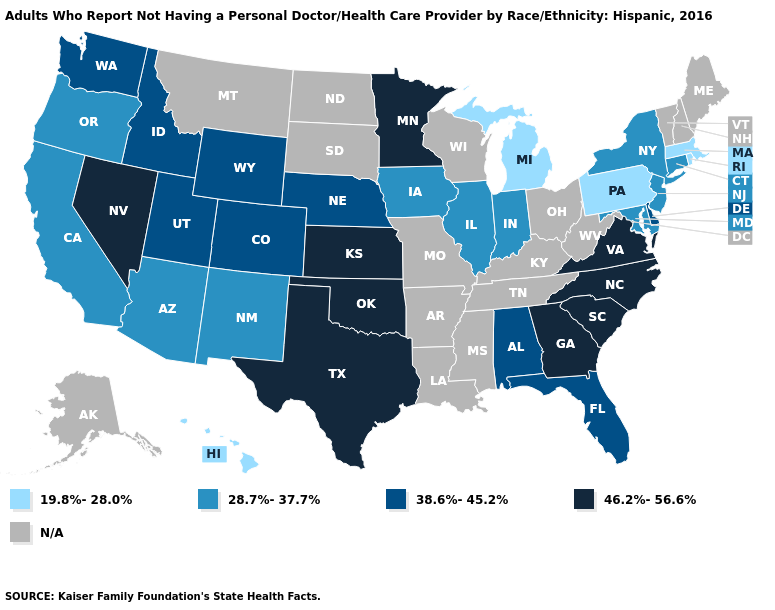Among the states that border Tennessee , which have the lowest value?
Keep it brief. Alabama. What is the value of Vermont?
Answer briefly. N/A. What is the value of West Virginia?
Quick response, please. N/A. Name the states that have a value in the range N/A?
Short answer required. Alaska, Arkansas, Kentucky, Louisiana, Maine, Mississippi, Missouri, Montana, New Hampshire, North Dakota, Ohio, South Dakota, Tennessee, Vermont, West Virginia, Wisconsin. Does Kansas have the highest value in the USA?
Keep it brief. Yes. Among the states that border South Carolina , which have the highest value?
Concise answer only. Georgia, North Carolina. Which states have the highest value in the USA?
Give a very brief answer. Georgia, Kansas, Minnesota, Nevada, North Carolina, Oklahoma, South Carolina, Texas, Virginia. What is the lowest value in states that border New York?
Keep it brief. 19.8%-28.0%. What is the value of Ohio?
Be succinct. N/A. What is the value of Louisiana?
Be succinct. N/A. Name the states that have a value in the range 28.7%-37.7%?
Concise answer only. Arizona, California, Connecticut, Illinois, Indiana, Iowa, Maryland, New Jersey, New Mexico, New York, Oregon. Name the states that have a value in the range 38.6%-45.2%?
Concise answer only. Alabama, Colorado, Delaware, Florida, Idaho, Nebraska, Utah, Washington, Wyoming. What is the value of West Virginia?
Give a very brief answer. N/A. What is the highest value in states that border Rhode Island?
Short answer required. 28.7%-37.7%. 